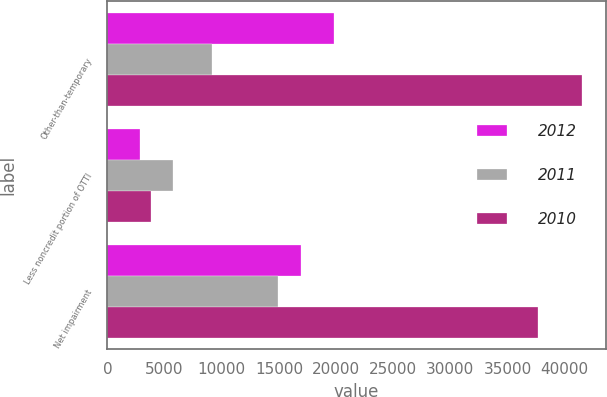<chart> <loc_0><loc_0><loc_500><loc_500><stacked_bar_chart><ecel><fcel>Other-than-temporary<fcel>Less noncredit portion of OTTI<fcel>Net impairment<nl><fcel>2012<fcel>19799<fcel>2874<fcel>16925<nl><fcel>2011<fcel>9190<fcel>5717<fcel>14907<nl><fcel>2010<fcel>41510<fcel>3840<fcel>37670<nl></chart> 